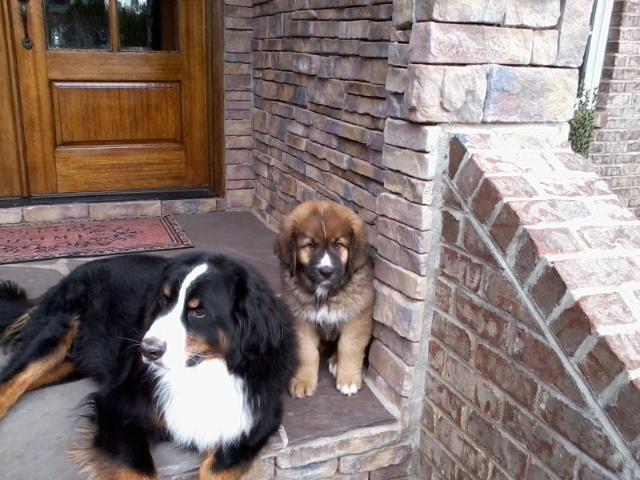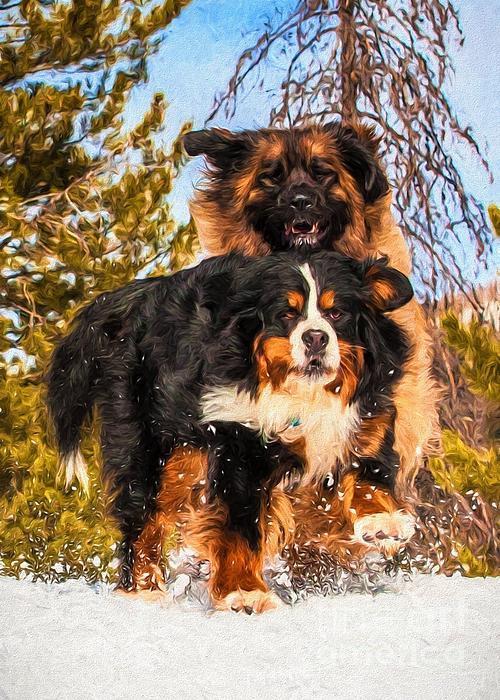The first image is the image on the left, the second image is the image on the right. Analyze the images presented: Is the assertion "At least one of the dogs in an image is not alone." valid? Answer yes or no. Yes. 